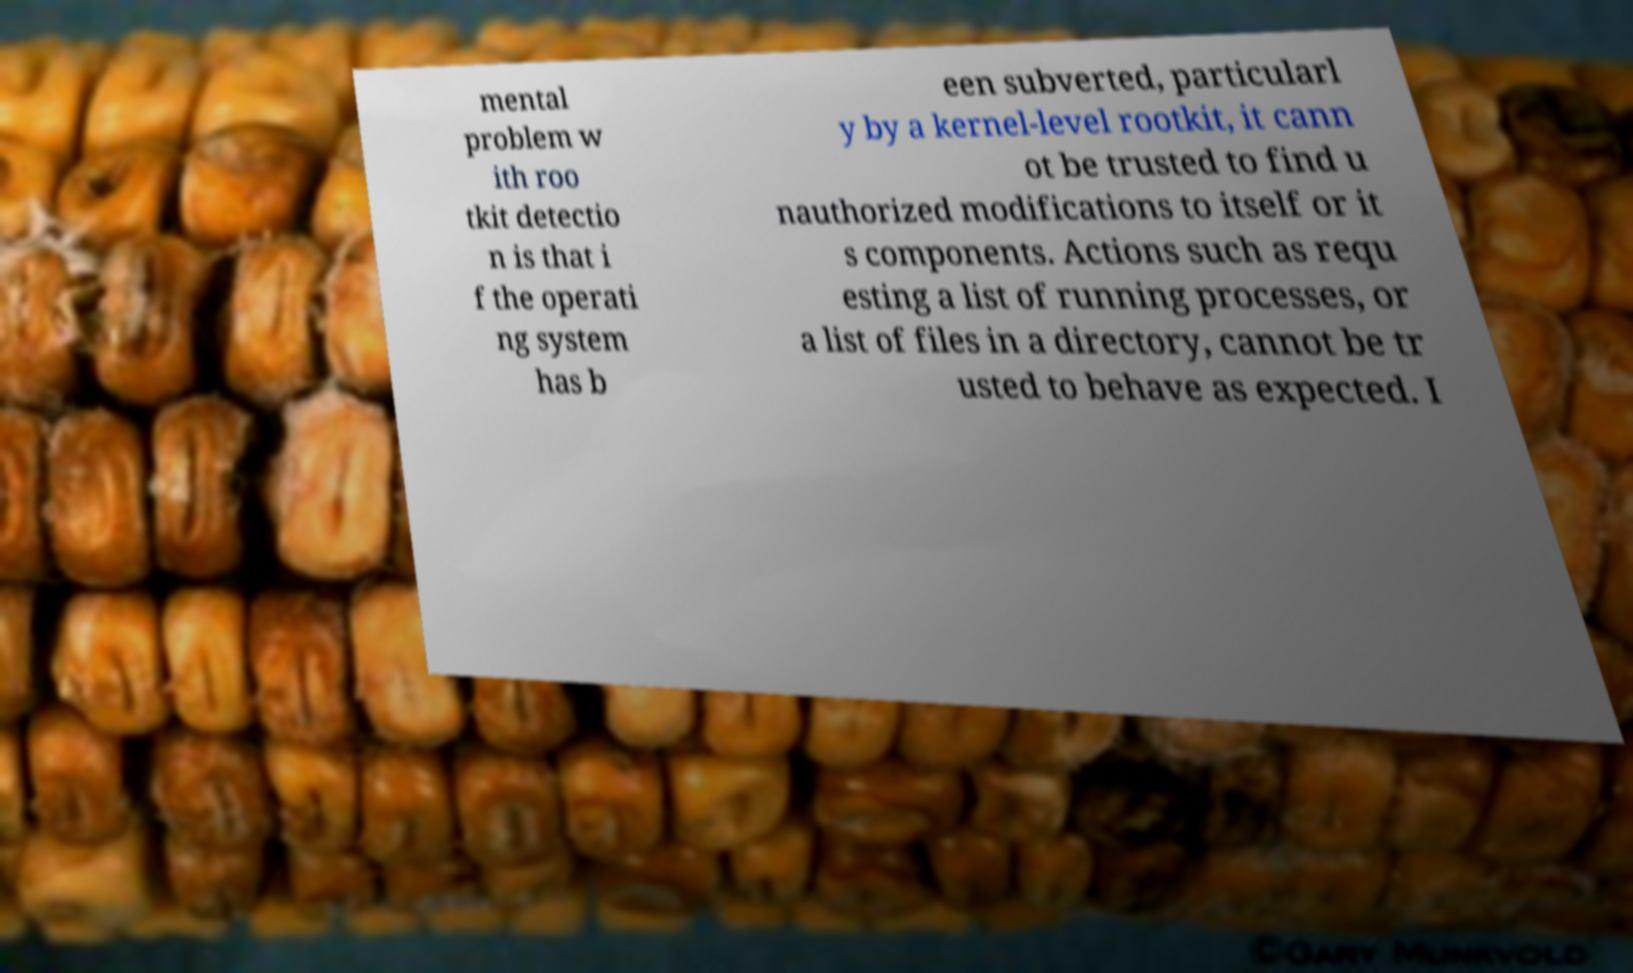There's text embedded in this image that I need extracted. Can you transcribe it verbatim? mental problem w ith roo tkit detectio n is that i f the operati ng system has b een subverted, particularl y by a kernel-level rootkit, it cann ot be trusted to find u nauthorized modifications to itself or it s components. Actions such as requ esting a list of running processes, or a list of files in a directory, cannot be tr usted to behave as expected. I 